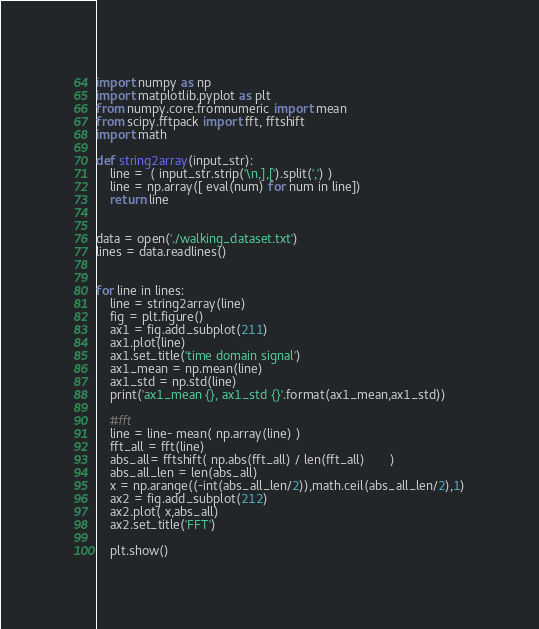Convert code to text. <code><loc_0><loc_0><loc_500><loc_500><_Python_>import numpy as np
import matplotlib.pyplot as plt
from numpy.core.fromnumeric import mean
from scipy.fftpack import fft, fftshift
import math

def string2array(input_str):
    line =  ( input_str.strip('\n,],[').split(',') ) 
    line = np.array([ eval(num) for num in line])
    return line


data = open('./walking_dataset.txt')
lines = data.readlines()


for line in lines:
    line = string2array(line)
    fig = plt.figure()
    ax1 = fig.add_subplot(211)
    ax1.plot(line)
    ax1.set_title('time domain signal')
    ax1_mean = np.mean(line)
    ax1_std = np.std(line)
    print('ax1_mean {}, ax1_std {}'.format(ax1_mean,ax1_std))

    #fft        
    line = line- mean( np.array(line) )
    fft_all = fft(line)
    abs_all= fftshift( np.abs(fft_all) / len(fft_all)       )
    abs_all_len = len(abs_all) 
    x = np.arange((-int(abs_all_len/2)),math.ceil(abs_all_len/2),1)
    ax2 = fig.add_subplot(212)
    ax2.plot( x,abs_all)   
    ax2.set_title('FFT')

    plt.show()</code> 